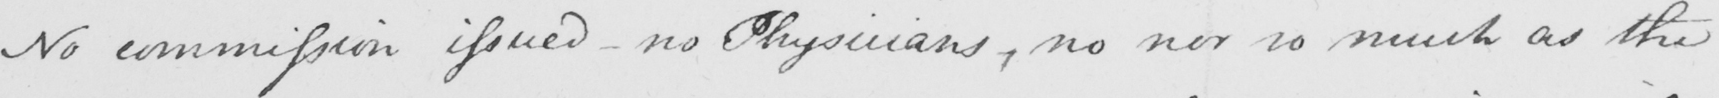What is written in this line of handwriting? No commission issued  _  no Physicians , no nor so much as the 